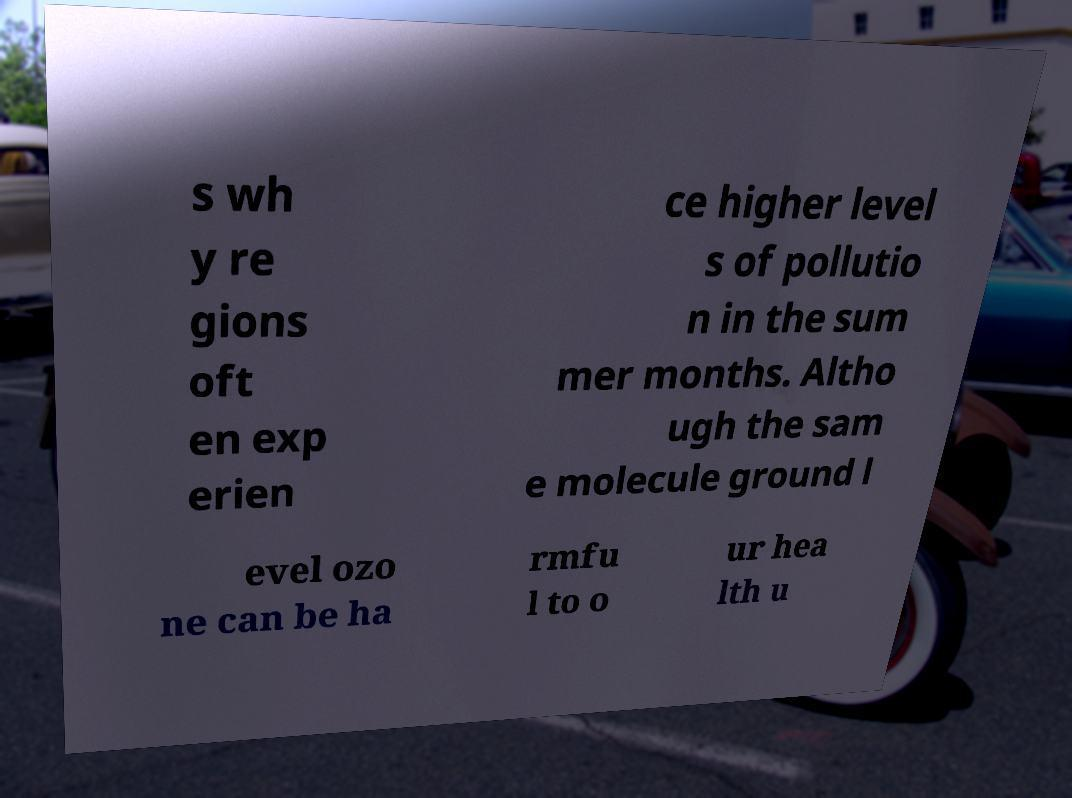There's text embedded in this image that I need extracted. Can you transcribe it verbatim? s wh y re gions oft en exp erien ce higher level s of pollutio n in the sum mer months. Altho ugh the sam e molecule ground l evel ozo ne can be ha rmfu l to o ur hea lth u 